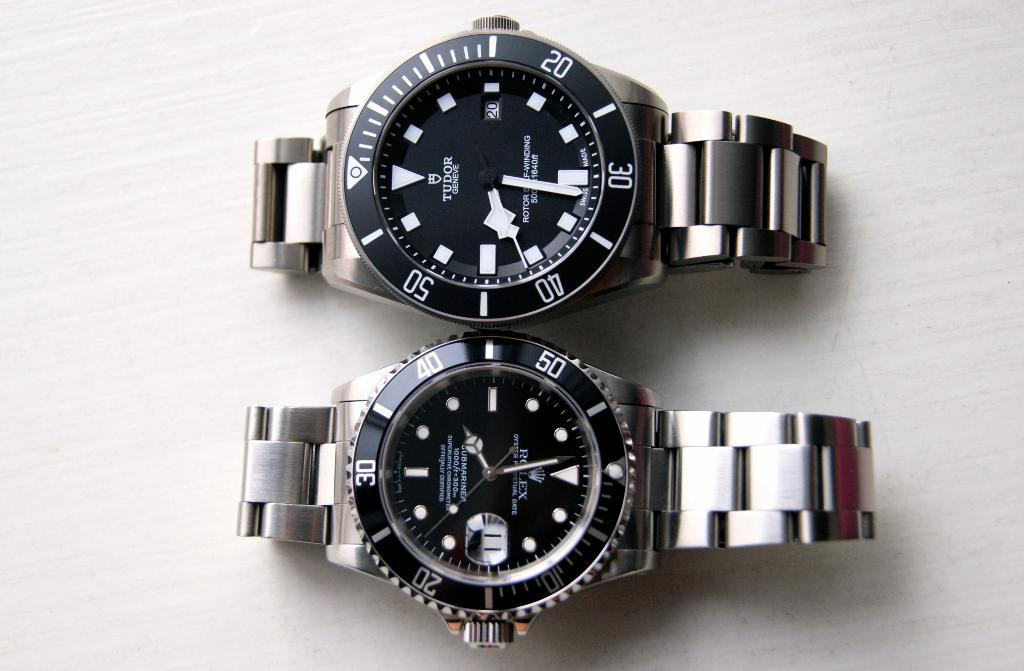How many watches are visible in the image? There are two watches in the image. Where are the watches located in the image? The watches are placed on a surface. What type of books can be seen on the yoke in the image? There is no yoke or books present in the image; it only features two watches placed on a surface. 